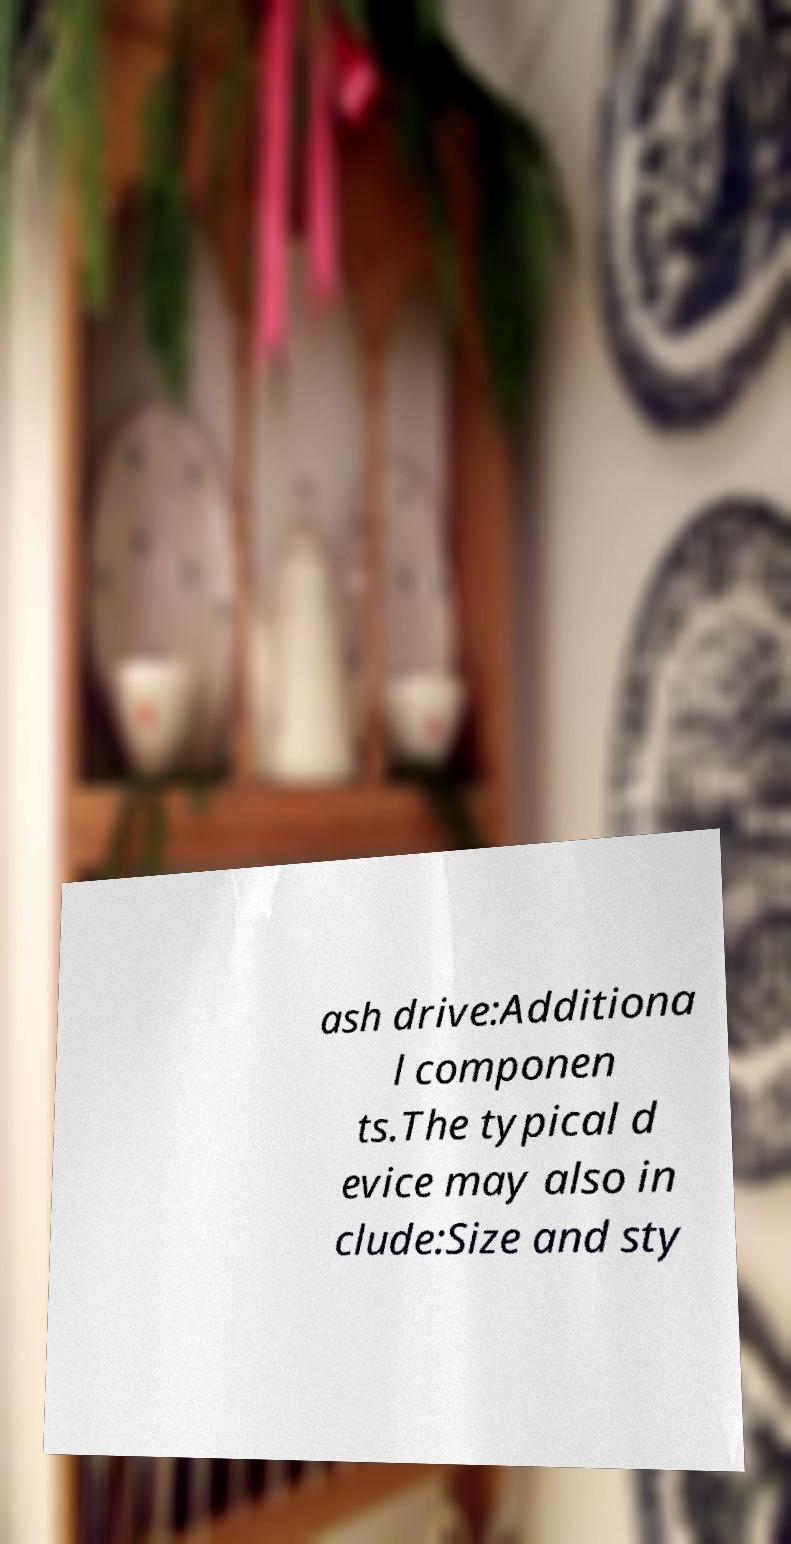What messages or text are displayed in this image? I need them in a readable, typed format. ash drive:Additiona l componen ts.The typical d evice may also in clude:Size and sty 